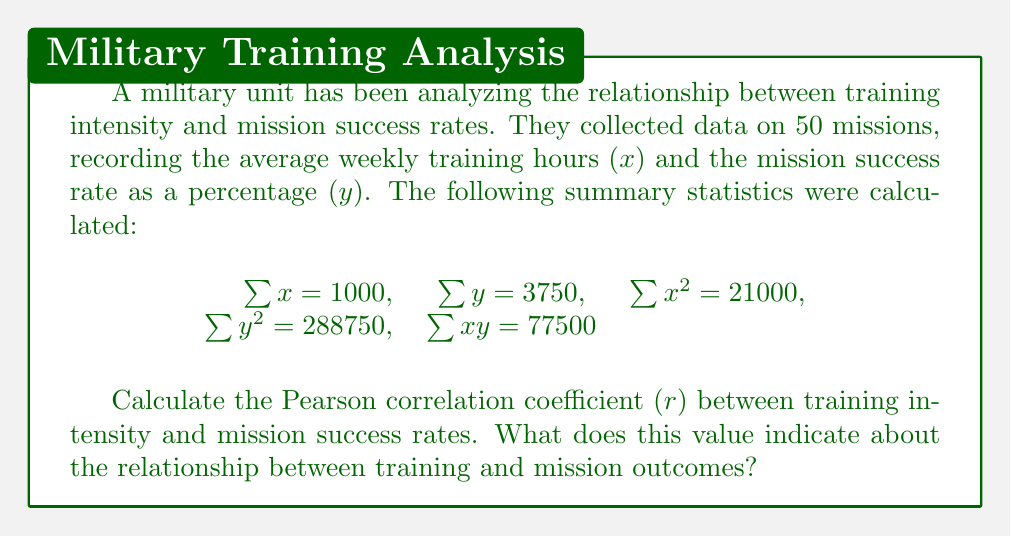Provide a solution to this math problem. To calculate the Pearson correlation coefficient (r), we'll use the formula:

$$r = \frac{n\sum xy - \sum x \sum y}{\sqrt{[n\sum x^2 - (\sum x)^2][n\sum y^2 - (\sum y)^2]}}$$

Where n is the number of data points (50 in this case).

Step 1: Calculate $n\sum xy - \sum x \sum y$
$50(77500) - (1000)(3750) = 3875000 - 3750000 = 125000$

Step 2: Calculate $n\sum x^2 - (\sum x)^2$
$50(21000) - (1000)^2 = 1050000 - 1000000 = 50000$

Step 3: Calculate $n\sum y^2 - (\sum y)^2$
$50(288750) - (3750)^2 = 14437500 - 14062500 = 375000$

Step 4: Multiply the results from steps 2 and 3
$50000 * 375000 = 18750000000$

Step 5: Take the square root of step 4
$\sqrt{18750000000} = 136930.64$

Step 6: Divide the result from step 1 by the result from step 5
$r = \frac{125000}{136930.64} = 0.9128$

The Pearson correlation coefficient (r) is approximately 0.9128. This value indicates a strong positive correlation between training intensity and mission success rates. As a veteran, you would interpret this as evidence that increased training hours are strongly associated with higher mission success rates, supporting the importance of rigorous preparation in military operations.
Answer: The Pearson correlation coefficient (r) is approximately 0.9128, indicating a strong positive correlation between training intensity and mission success rates. 